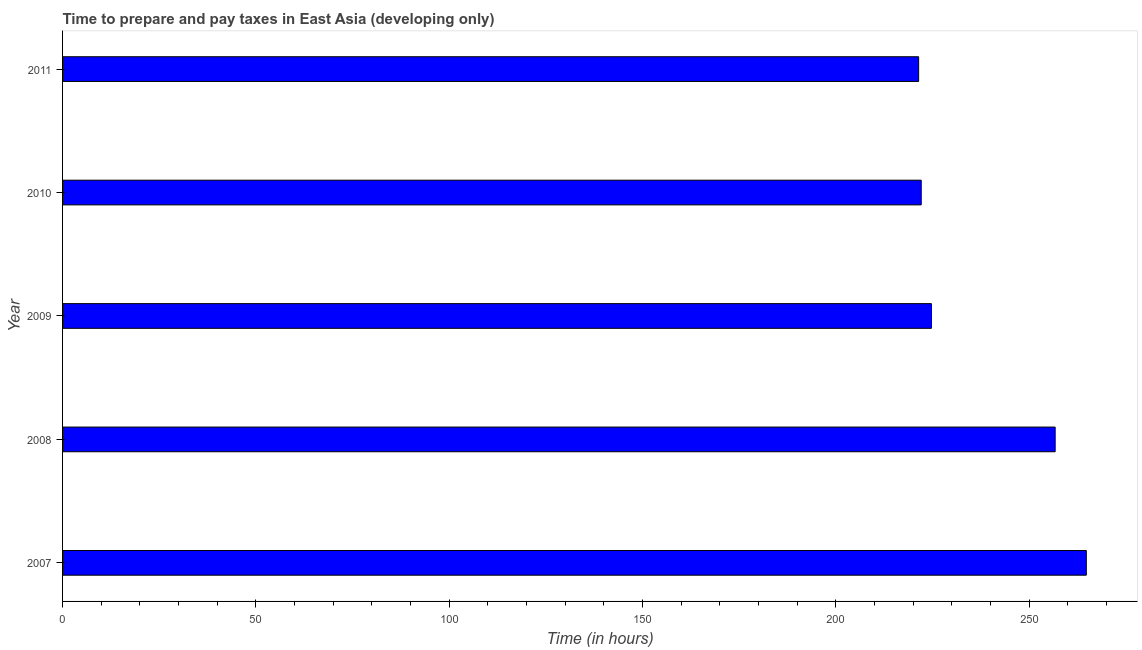Does the graph contain grids?
Keep it short and to the point. No. What is the title of the graph?
Provide a short and direct response. Time to prepare and pay taxes in East Asia (developing only). What is the label or title of the X-axis?
Keep it short and to the point. Time (in hours). What is the label or title of the Y-axis?
Your answer should be compact. Year. What is the time to prepare and pay taxes in 2011?
Keep it short and to the point. 221.39. Across all years, what is the maximum time to prepare and pay taxes?
Your response must be concise. 264.75. Across all years, what is the minimum time to prepare and pay taxes?
Make the answer very short. 221.39. What is the sum of the time to prepare and pay taxes?
Offer a terse response. 1189.58. What is the difference between the time to prepare and pay taxes in 2007 and 2010?
Provide a short and direct response. 42.69. What is the average time to prepare and pay taxes per year?
Ensure brevity in your answer.  237.92. What is the median time to prepare and pay taxes?
Your response must be concise. 224.69. In how many years, is the time to prepare and pay taxes greater than 240 hours?
Keep it short and to the point. 2. Do a majority of the years between 2008 and 2010 (inclusive) have time to prepare and pay taxes greater than 30 hours?
Offer a terse response. Yes. Is the time to prepare and pay taxes in 2009 less than that in 2011?
Give a very brief answer. No. Is the difference between the time to prepare and pay taxes in 2009 and 2011 greater than the difference between any two years?
Offer a terse response. No. What is the difference between the highest and the second highest time to prepare and pay taxes?
Ensure brevity in your answer.  8.06. What is the difference between the highest and the lowest time to prepare and pay taxes?
Give a very brief answer. 43.36. Are the values on the major ticks of X-axis written in scientific E-notation?
Ensure brevity in your answer.  No. What is the Time (in hours) in 2007?
Give a very brief answer. 264.75. What is the Time (in hours) in 2008?
Your answer should be compact. 256.69. What is the Time (in hours) in 2009?
Provide a short and direct response. 224.69. What is the Time (in hours) of 2010?
Your answer should be very brief. 222.06. What is the Time (in hours) of 2011?
Offer a terse response. 221.39. What is the difference between the Time (in hours) in 2007 and 2008?
Make the answer very short. 8.06. What is the difference between the Time (in hours) in 2007 and 2009?
Keep it short and to the point. 40.06. What is the difference between the Time (in hours) in 2007 and 2010?
Provide a short and direct response. 42.69. What is the difference between the Time (in hours) in 2007 and 2011?
Your response must be concise. 43.36. What is the difference between the Time (in hours) in 2008 and 2010?
Provide a succinct answer. 34.64. What is the difference between the Time (in hours) in 2008 and 2011?
Your answer should be very brief. 35.31. What is the difference between the Time (in hours) in 2009 and 2010?
Offer a terse response. 2.64. What is the difference between the Time (in hours) in 2009 and 2011?
Provide a short and direct response. 3.31. What is the difference between the Time (in hours) in 2010 and 2011?
Make the answer very short. 0.67. What is the ratio of the Time (in hours) in 2007 to that in 2008?
Provide a short and direct response. 1.03. What is the ratio of the Time (in hours) in 2007 to that in 2009?
Provide a succinct answer. 1.18. What is the ratio of the Time (in hours) in 2007 to that in 2010?
Provide a short and direct response. 1.19. What is the ratio of the Time (in hours) in 2007 to that in 2011?
Make the answer very short. 1.2. What is the ratio of the Time (in hours) in 2008 to that in 2009?
Your answer should be compact. 1.14. What is the ratio of the Time (in hours) in 2008 to that in 2010?
Your response must be concise. 1.16. What is the ratio of the Time (in hours) in 2008 to that in 2011?
Your answer should be compact. 1.16. What is the ratio of the Time (in hours) in 2009 to that in 2010?
Your answer should be compact. 1.01. 